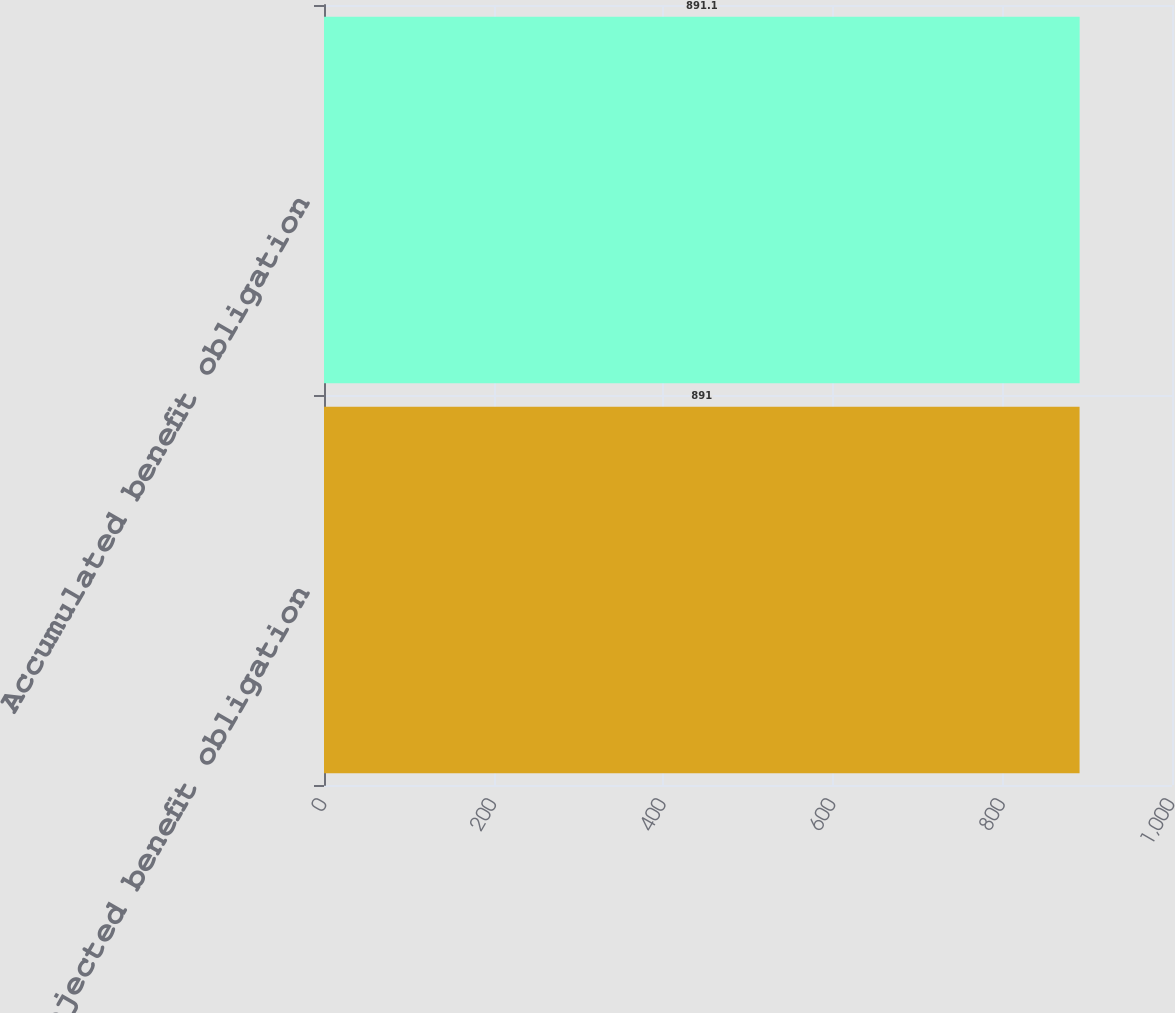Convert chart. <chart><loc_0><loc_0><loc_500><loc_500><bar_chart><fcel>Projected benefit obligation<fcel>Accumulated benefit obligation<nl><fcel>891<fcel>891.1<nl></chart> 